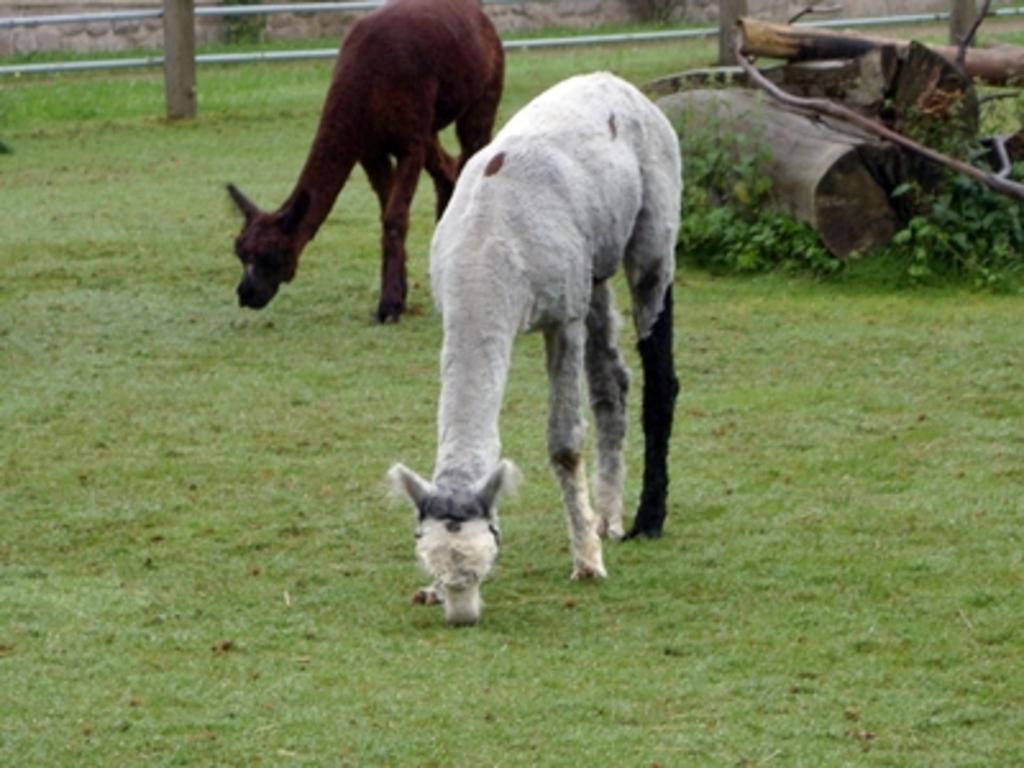Can you describe this image briefly? In the image there are two animals standing on the ground. On the ground there is grass. Behind them there are wooden logs. At the top of the image there is fencing. 